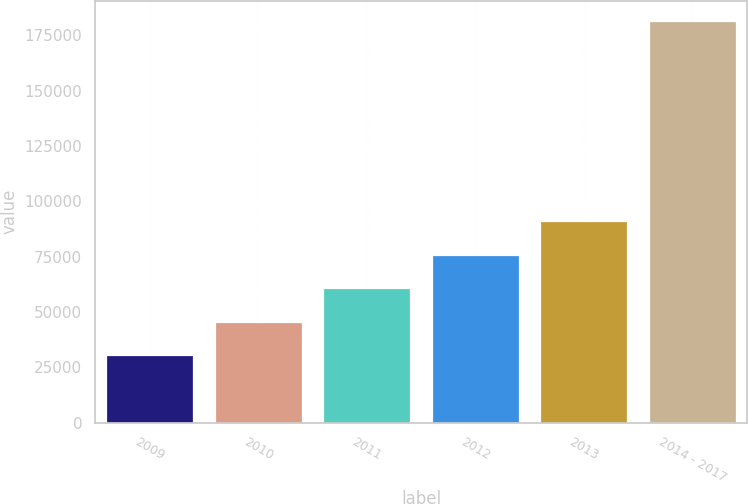<chart> <loc_0><loc_0><loc_500><loc_500><bar_chart><fcel>2009<fcel>2010<fcel>2011<fcel>2012<fcel>2013<fcel>2014 - 2017<nl><fcel>30432<fcel>45548<fcel>60664<fcel>75780<fcel>90896<fcel>181592<nl></chart> 